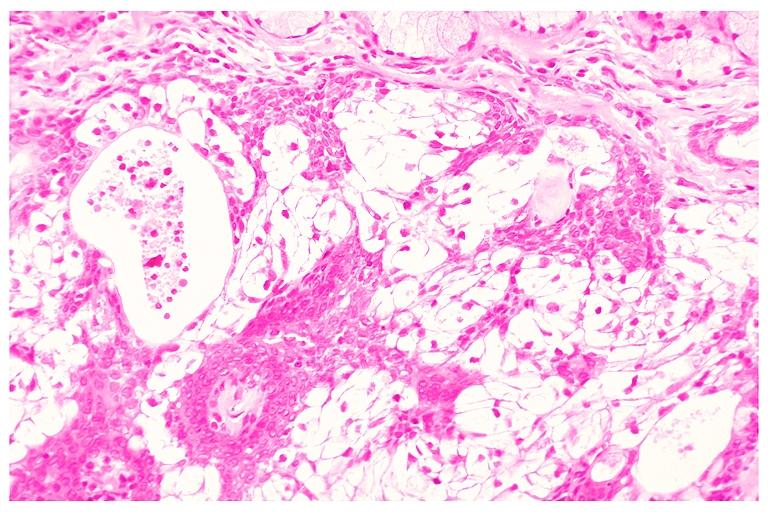does bilateral cleft palate show mucoepidermoid carcinoma?
Answer the question using a single word or phrase. No 